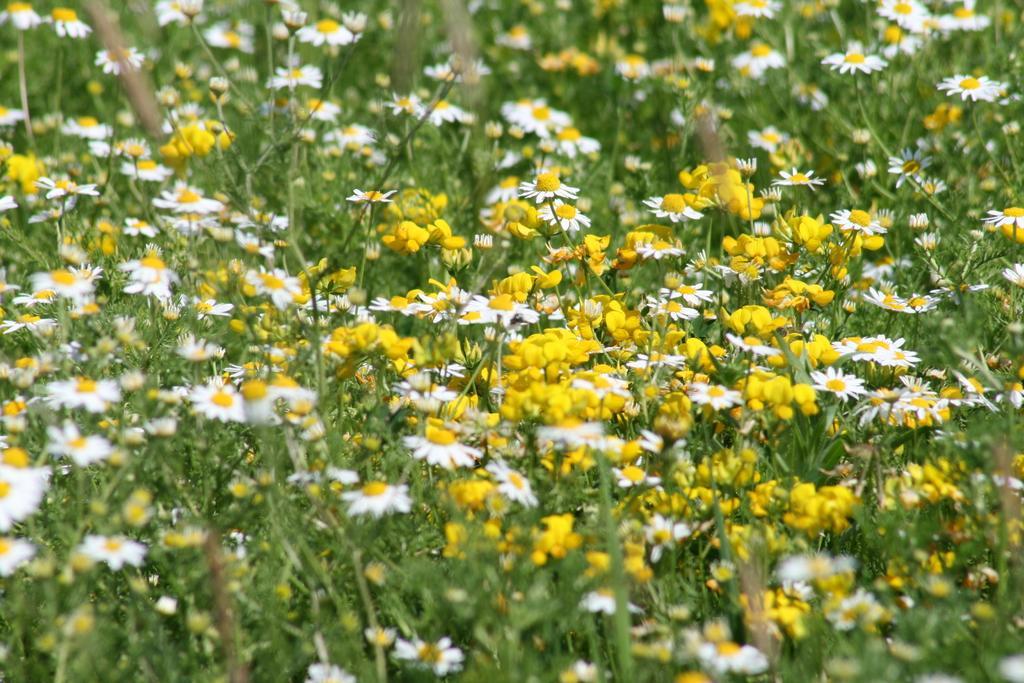Please provide a concise description of this image. Here we can see plants with yellow and white color flowers. 